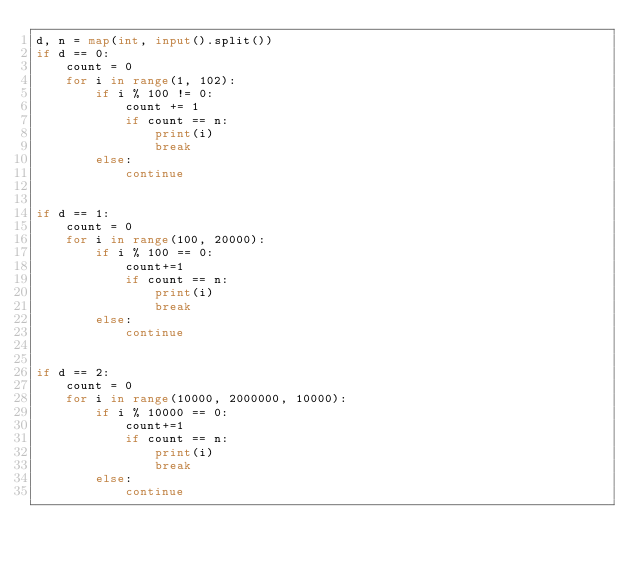<code> <loc_0><loc_0><loc_500><loc_500><_Python_>d, n = map(int, input().split())
if d == 0:
    count = 0
    for i in range(1, 102):
        if i % 100 != 0:
            count += 1
            if count == n:
                print(i)
                break
        else:
            continue
        

if d == 1:
    count = 0
    for i in range(100, 20000):
        if i % 100 == 0:
            count+=1
            if count == n:
                print(i)
                break
        else:
            continue
        

if d == 2:
    count = 0
    for i in range(10000, 2000000, 10000):
        if i % 10000 == 0:
            count+=1
            if count == n:
                print(i)
                break
        else:
            continue


</code> 